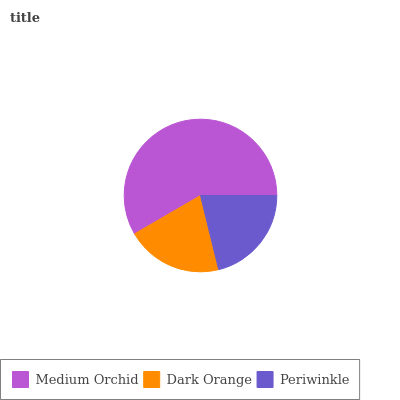Is Dark Orange the minimum?
Answer yes or no. Yes. Is Medium Orchid the maximum?
Answer yes or no. Yes. Is Periwinkle the minimum?
Answer yes or no. No. Is Periwinkle the maximum?
Answer yes or no. No. Is Periwinkle greater than Dark Orange?
Answer yes or no. Yes. Is Dark Orange less than Periwinkle?
Answer yes or no. Yes. Is Dark Orange greater than Periwinkle?
Answer yes or no. No. Is Periwinkle less than Dark Orange?
Answer yes or no. No. Is Periwinkle the high median?
Answer yes or no. Yes. Is Periwinkle the low median?
Answer yes or no. Yes. Is Dark Orange the high median?
Answer yes or no. No. Is Dark Orange the low median?
Answer yes or no. No. 